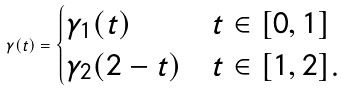<formula> <loc_0><loc_0><loc_500><loc_500>\gamma ( t ) = \begin{cases} \gamma _ { 1 } ( t ) & t \in [ 0 , 1 ] \\ \gamma _ { 2 } ( 2 - t ) & t \in [ 1 , 2 ] . \end{cases}</formula> 